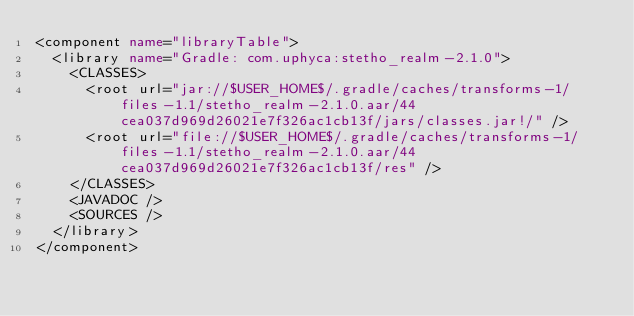<code> <loc_0><loc_0><loc_500><loc_500><_XML_><component name="libraryTable">
  <library name="Gradle: com.uphyca:stetho_realm-2.1.0">
    <CLASSES>
      <root url="jar://$USER_HOME$/.gradle/caches/transforms-1/files-1.1/stetho_realm-2.1.0.aar/44cea037d969d26021e7f326ac1cb13f/jars/classes.jar!/" />
      <root url="file://$USER_HOME$/.gradle/caches/transforms-1/files-1.1/stetho_realm-2.1.0.aar/44cea037d969d26021e7f326ac1cb13f/res" />
    </CLASSES>
    <JAVADOC />
    <SOURCES />
  </library>
</component></code> 